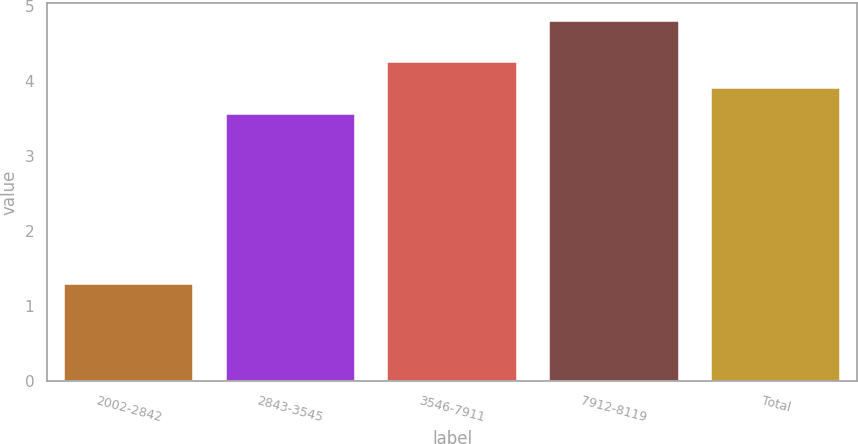<chart> <loc_0><loc_0><loc_500><loc_500><bar_chart><fcel>2002-2842<fcel>2843-3545<fcel>3546-7911<fcel>7912-8119<fcel>Total<nl><fcel>1.29<fcel>3.56<fcel>4.26<fcel>4.8<fcel>3.91<nl></chart> 